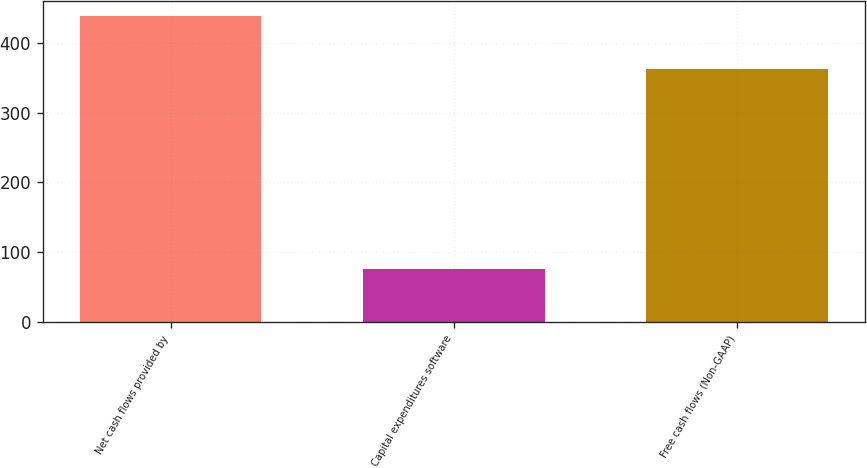Convert chart to OTSL. <chart><loc_0><loc_0><loc_500><loc_500><bar_chart><fcel>Net cash flows provided by<fcel>Capital expenditures software<fcel>Free cash flows (Non-GAAP)<nl><fcel>437.7<fcel>75.5<fcel>362.2<nl></chart> 